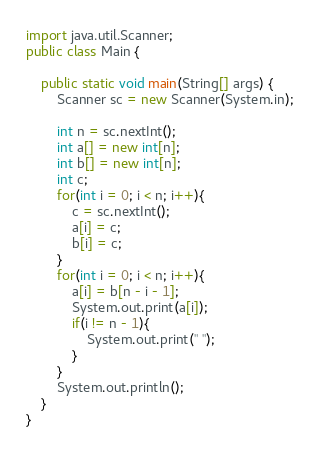<code> <loc_0><loc_0><loc_500><loc_500><_Java_>import java.util.Scanner;
public class Main {

    public static void main(String[] args) {
        Scanner sc = new Scanner(System.in);

        int n = sc.nextInt();
        int a[] = new int[n];
        int b[] = new int[n];
        int c;
        for(int i = 0; i < n; i++){
        	c = sc.nextInt();
        	a[i] = c;
        	b[i] = c;
        }
        for(int i = 0; i < n; i++){
        	a[i] = b[n - i - 1];
        	System.out.print(a[i]);
        	if(i != n - 1){
        		System.out.print(" ");
        	}
        }
        System.out.println();
    }
}
</code> 